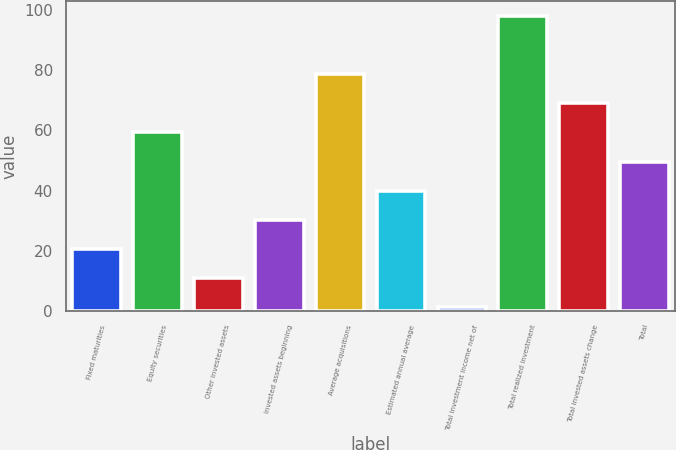<chart> <loc_0><loc_0><loc_500><loc_500><bar_chart><fcel>Fixed maturities<fcel>Equity securities<fcel>Other invested assets<fcel>Invested assets beginning<fcel>Average acquisitions<fcel>Estimated annual average<fcel>Total investment income net of<fcel>Total realized investment<fcel>Total invested assets change<fcel>Total<nl><fcel>20.68<fcel>59.32<fcel>11.02<fcel>30.34<fcel>78.64<fcel>40<fcel>1.36<fcel>98<fcel>68.98<fcel>49.66<nl></chart> 